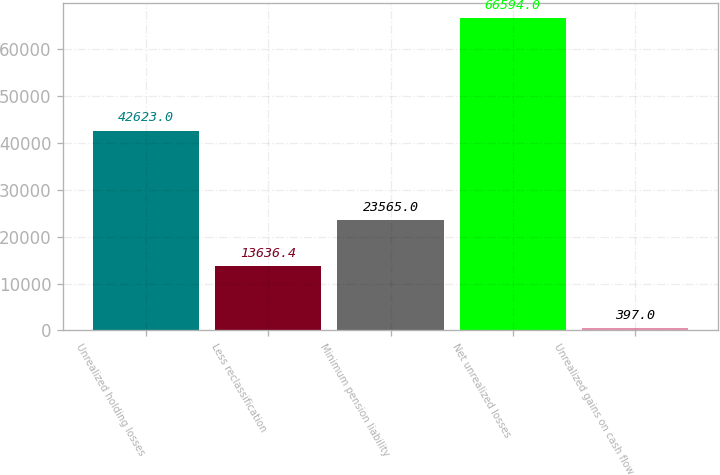Convert chart. <chart><loc_0><loc_0><loc_500><loc_500><bar_chart><fcel>Unrealized holding losses<fcel>Less reclassification<fcel>Minimum pension liability<fcel>Net unrealized losses<fcel>Unrealized gains on cash flow<nl><fcel>42623<fcel>13636.4<fcel>23565<fcel>66594<fcel>397<nl></chart> 